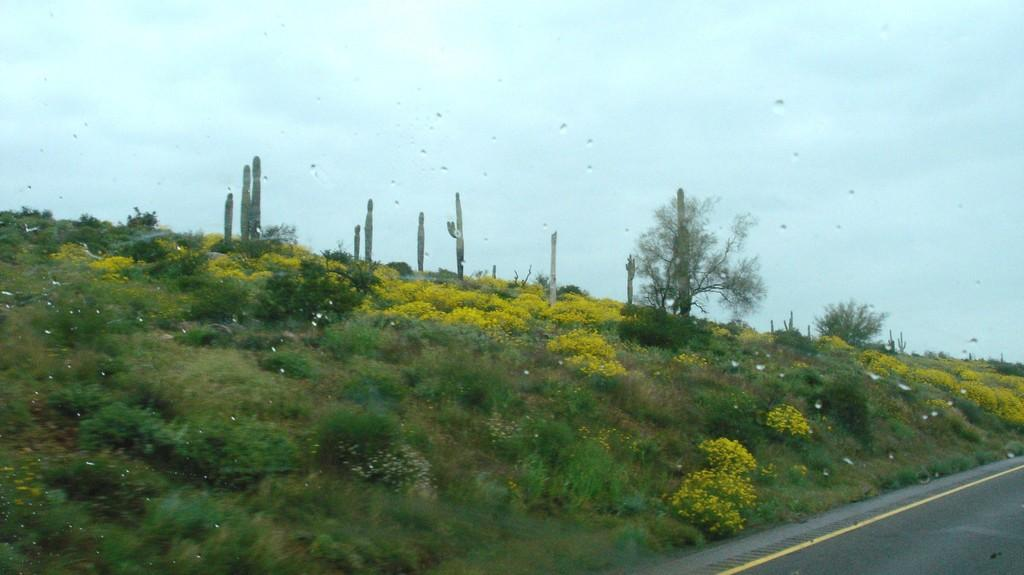What is the perspective of the image? The image is taken from a vehicle. What type of vegetation can be seen in the front of the image? There is green grass, small plants, and yellow flowers in the front of the image. What part of the natural environment is visible in the image? The sky is visible in the image. What type of linen can be seen hanging from the vehicle in the image? There is no linen visible in the image, nor is there any indication that the vehicle has any linen hanging from it. 